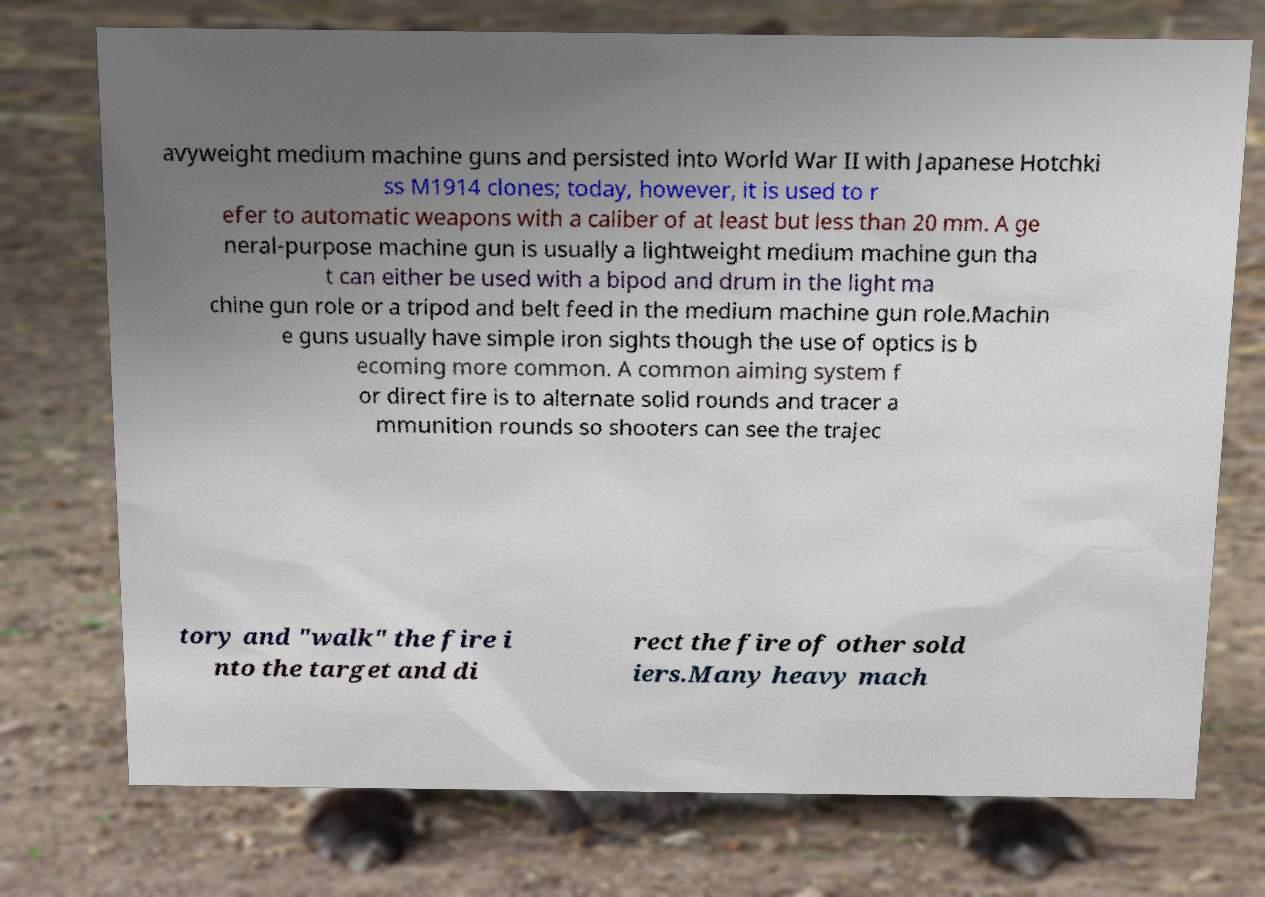I need the written content from this picture converted into text. Can you do that? avyweight medium machine guns and persisted into World War II with Japanese Hotchki ss M1914 clones; today, however, it is used to r efer to automatic weapons with a caliber of at least but less than 20 mm. A ge neral-purpose machine gun is usually a lightweight medium machine gun tha t can either be used with a bipod and drum in the light ma chine gun role or a tripod and belt feed in the medium machine gun role.Machin e guns usually have simple iron sights though the use of optics is b ecoming more common. A common aiming system f or direct fire is to alternate solid rounds and tracer a mmunition rounds so shooters can see the trajec tory and "walk" the fire i nto the target and di rect the fire of other sold iers.Many heavy mach 